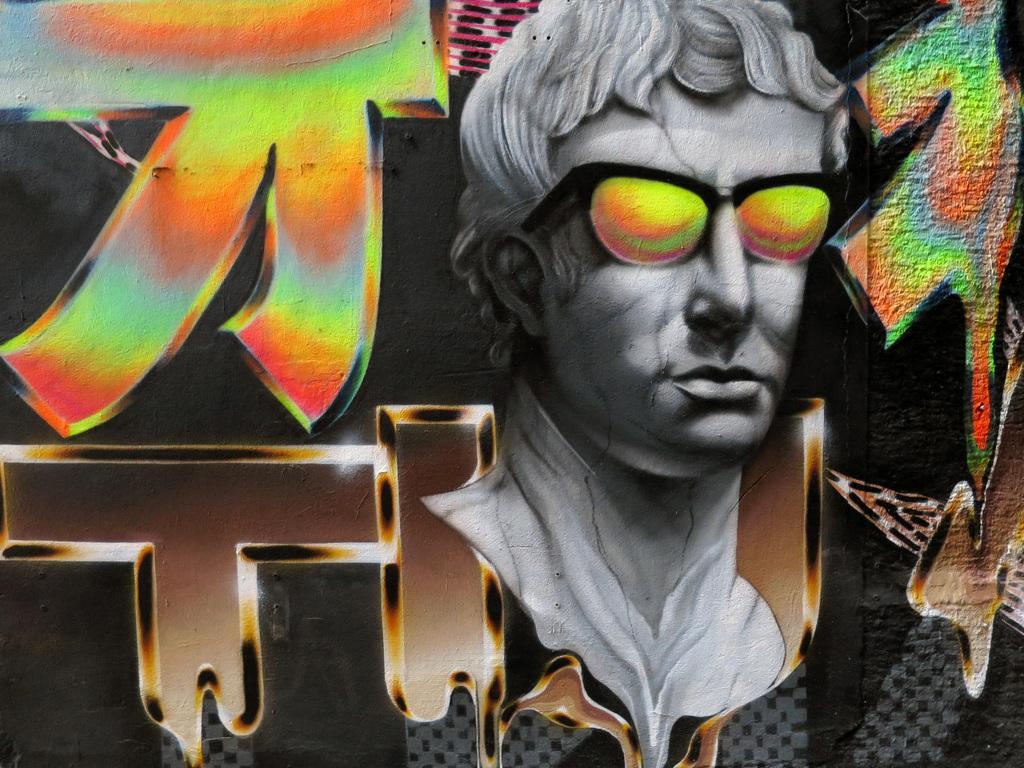How would you summarize this image in a sentence or two? In this picture we can observe painting of a man wearing spectacles. The painting is in grey color. We can observe green, orange and red colors. In this picture there is a black color background. 